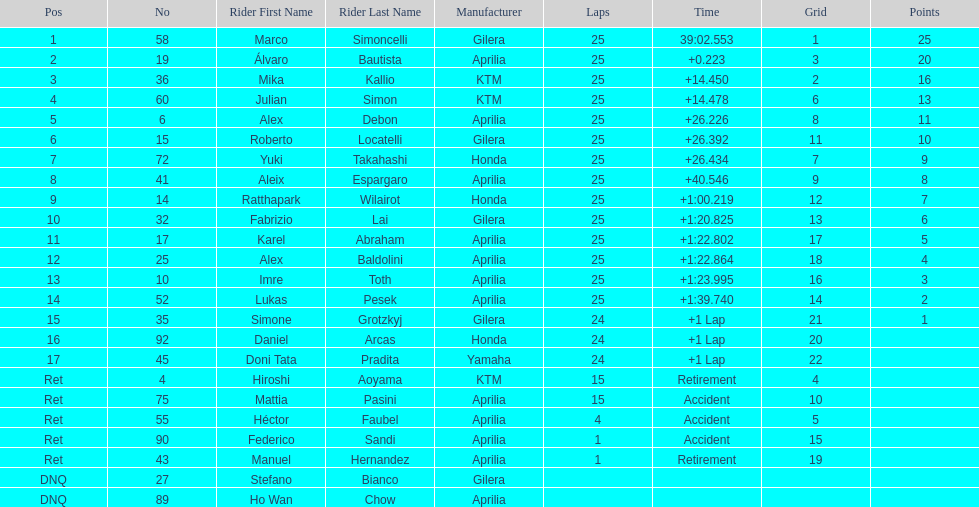The total amount of riders who did not qualify 2. 